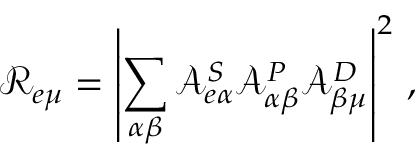Convert formula to latex. <formula><loc_0><loc_0><loc_500><loc_500>\mathcal { R } _ { e \mu } = \left | \sum _ { \alpha \beta } \mathcal { A } _ { e \alpha } ^ { S } \mathcal { A } _ { \alpha \beta } ^ { P } \mathcal { A } _ { \beta \mu } ^ { D } \right | ^ { 2 } \, ,</formula> 